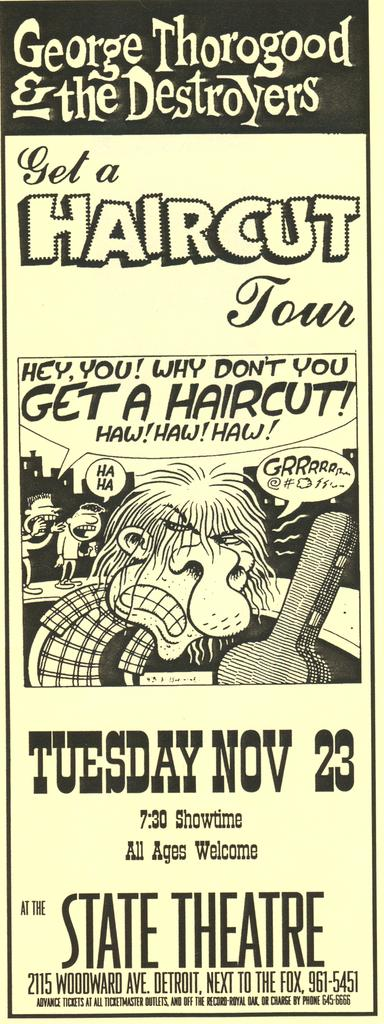Provide a one-sentence caption for the provided image. a poster that invites you to get a haircut  on nov 23. 